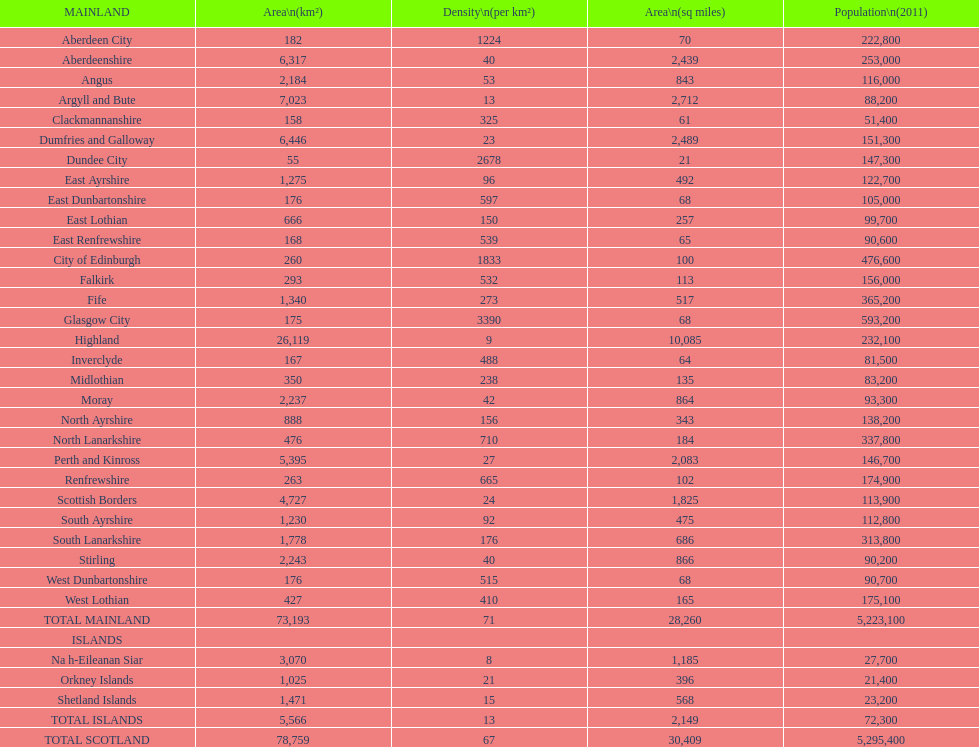What is the average population density in mainland cities? 71. 